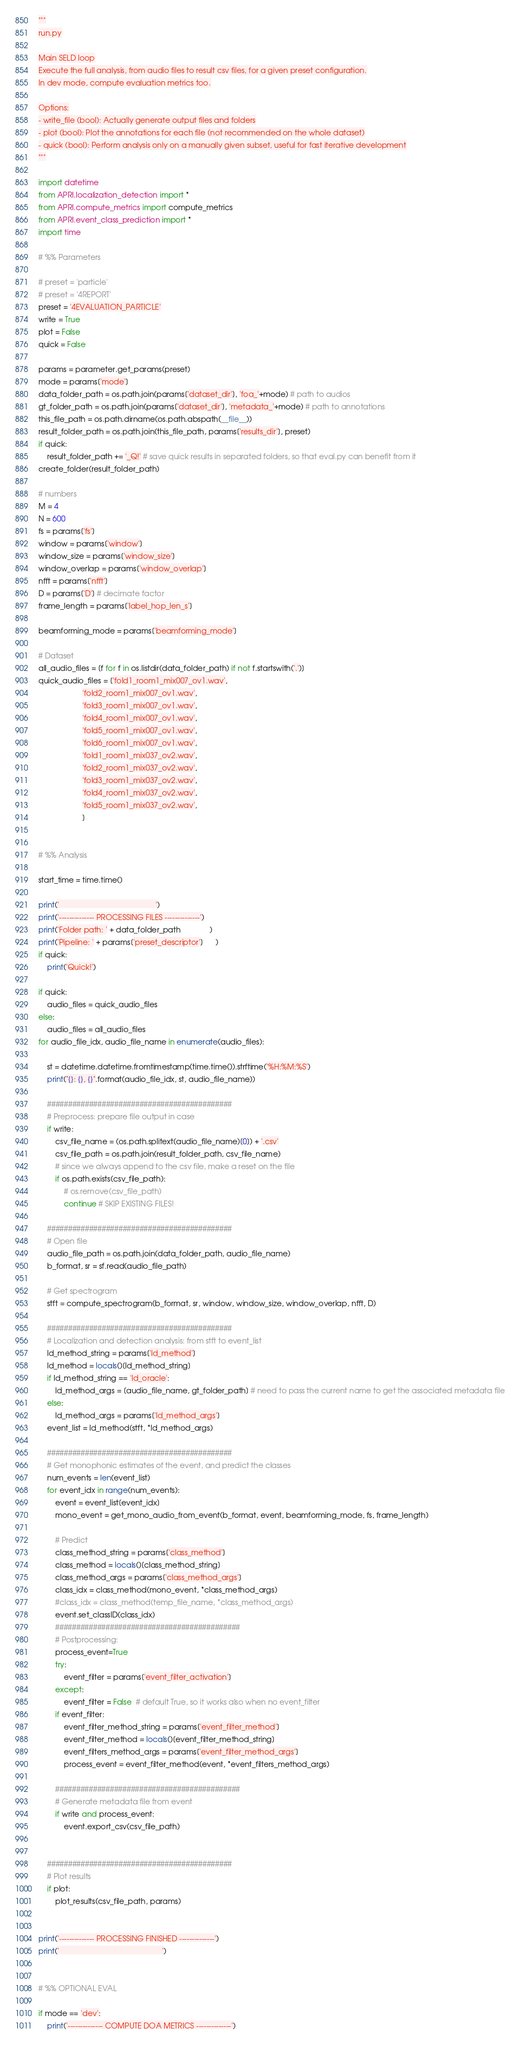<code> <loc_0><loc_0><loc_500><loc_500><_Python_>"""
run.py

Main SELD loop
Execute the full analysis, from audio files to result csv files, for a given preset configuration.
In dev mode, compute evaluation metrics too.

Options:
- write_file (bool): Actually generate output files and folders
- plot (bool): Plot the annotations for each file (not recommended on the whole dataset)
- quick (bool): Perform analysis only on a manually given subset, useful for fast iterative development
"""

import datetime
from APRI.localization_detection import *
from APRI.compute_metrics import compute_metrics
from APRI.event_class_prediction import *
import time

# %% Parameters

# preset = 'particle'
# preset = '4REPORT'
preset = '4EVALUATION_PARTICLE'
write = True
plot = False
quick = False

params = parameter.get_params(preset)
mode = params['mode']
data_folder_path = os.path.join(params['dataset_dir'], 'foa_'+mode) # path to audios
gt_folder_path = os.path.join(params['dataset_dir'], 'metadata_'+mode) # path to annotations
this_file_path = os.path.dirname(os.path.abspath(__file__))
result_folder_path = os.path.join(this_file_path, params['results_dir'], preset)
if quick:
    result_folder_path += '_Q!' # save quick results in separated folders, so that eval.py can benefit from it
create_folder(result_folder_path)

# numbers
M = 4
N = 600
fs = params['fs']
window = params['window']
window_size = params['window_size']
window_overlap = params['window_overlap']
nfft = params['nfft']
D = params['D'] # decimate factor
frame_length = params['label_hop_len_s']

beamforming_mode = params['beamforming_mode']

# Dataset
all_audio_files = [f for f in os.listdir(data_folder_path) if not f.startswith('.')]
quick_audio_files = ['fold1_room1_mix007_ov1.wav',
                     'fold2_room1_mix007_ov1.wav',
                     'fold3_room1_mix007_ov1.wav',
                     'fold4_room1_mix007_ov1.wav',
                     'fold5_room1_mix007_ov1.wav',
                     'fold6_room1_mix007_ov1.wav',
                     'fold1_room1_mix037_ov2.wav',
                     'fold2_room1_mix037_ov2.wav',
                     'fold3_room1_mix037_ov2.wav',
                     'fold4_room1_mix037_ov2.wav',
                     'fold5_room1_mix037_ov2.wav',
                     ]


# %% Analysis

start_time = time.time()

print('                                              ')
print('-------------- PROCESSING FILES --------------')
print('Folder path: ' + data_folder_path              )
print('Pipeline: ' + params['preset_descriptor']      )
if quick:
    print('Quick!')

if quick:
    audio_files = quick_audio_files
else:
    audio_files = all_audio_files
for audio_file_idx, audio_file_name in enumerate(audio_files):

    st = datetime.datetime.fromtimestamp(time.time()).strftime('%H:%M:%S')
    print("{}: {}, {}".format(audio_file_idx, st, audio_file_name))

    ############################################
    # Preprocess: prepare file output in case
    if write:
        csv_file_name = (os.path.splitext(audio_file_name)[0]) + '.csv'
        csv_file_path = os.path.join(result_folder_path, csv_file_name)
        # since we always append to the csv file, make a reset on the file
        if os.path.exists(csv_file_path):
            # os.remove(csv_file_path)
            continue # SKIP EXISTING FILES!

    ############################################
    # Open file
    audio_file_path = os.path.join(data_folder_path, audio_file_name)
    b_format, sr = sf.read(audio_file_path)

    # Get spectrogram
    stft = compute_spectrogram(b_format, sr, window, window_size, window_overlap, nfft, D)

    ############################################
    # Localization and detection analysis: from stft to event_list
    ld_method_string = params['ld_method']
    ld_method = locals()[ld_method_string]
    if ld_method_string == 'ld_oracle':
        ld_method_args = [audio_file_name, gt_folder_path] # need to pass the current name to get the associated metadata file
    else:
        ld_method_args = params['ld_method_args']
    event_list = ld_method(stft, *ld_method_args)

    ############################################
    # Get monophonic estimates of the event, and predict the classes
    num_events = len(event_list)
    for event_idx in range(num_events):
        event = event_list[event_idx]
        mono_event = get_mono_audio_from_event(b_format, event, beamforming_mode, fs, frame_length)

        # Predict
        class_method_string = params['class_method']
        class_method = locals()[class_method_string]
        class_method_args = params['class_method_args']
        class_idx = class_method(mono_event, *class_method_args)
        #class_idx = class_method(temp_file_name, *class_method_args)
        event.set_classID(class_idx)
        ############################################
        # Postprocessing:
        process_event=True
        try:
            event_filter = params['event_filter_activation']
        except:
            event_filter = False  # default True, so it works also when no event_filter
        if event_filter:
            event_filter_method_string = params['event_filter_method']
            event_filter_method = locals()[event_filter_method_string]
            event_filters_method_args = params['event_filter_method_args']
            process_event = event_filter_method(event, *event_filters_method_args)

        ############################################
        # Generate metadata file from event
        if write and process_event:
            event.export_csv(csv_file_path)


    ############################################
    # Plot results
    if plot:
        plot_results(csv_file_path, params)


print('-------------- PROCESSING FINISHED --------------')
print('                                                 ')


# %% OPTIONAL EVAL

if mode == 'dev':
    print('-------------- COMPUTE DOA METRICS --------------')</code> 